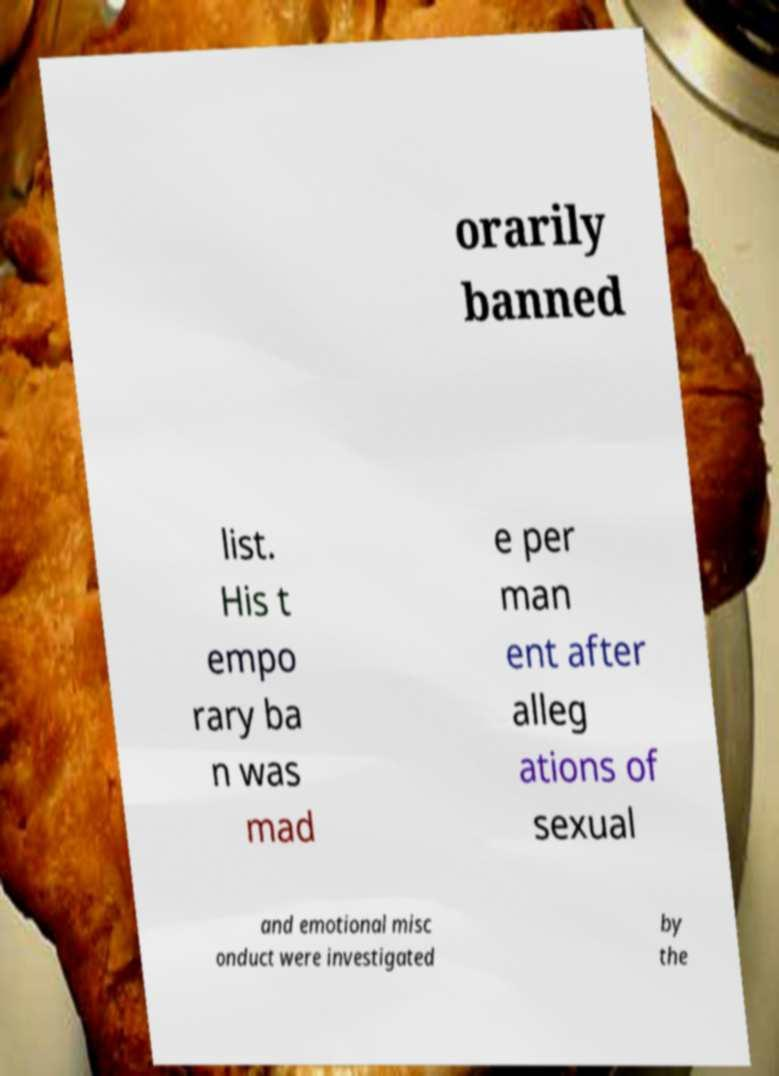Could you assist in decoding the text presented in this image and type it out clearly? orarily banned list. His t empo rary ba n was mad e per man ent after alleg ations of sexual and emotional misc onduct were investigated by the 